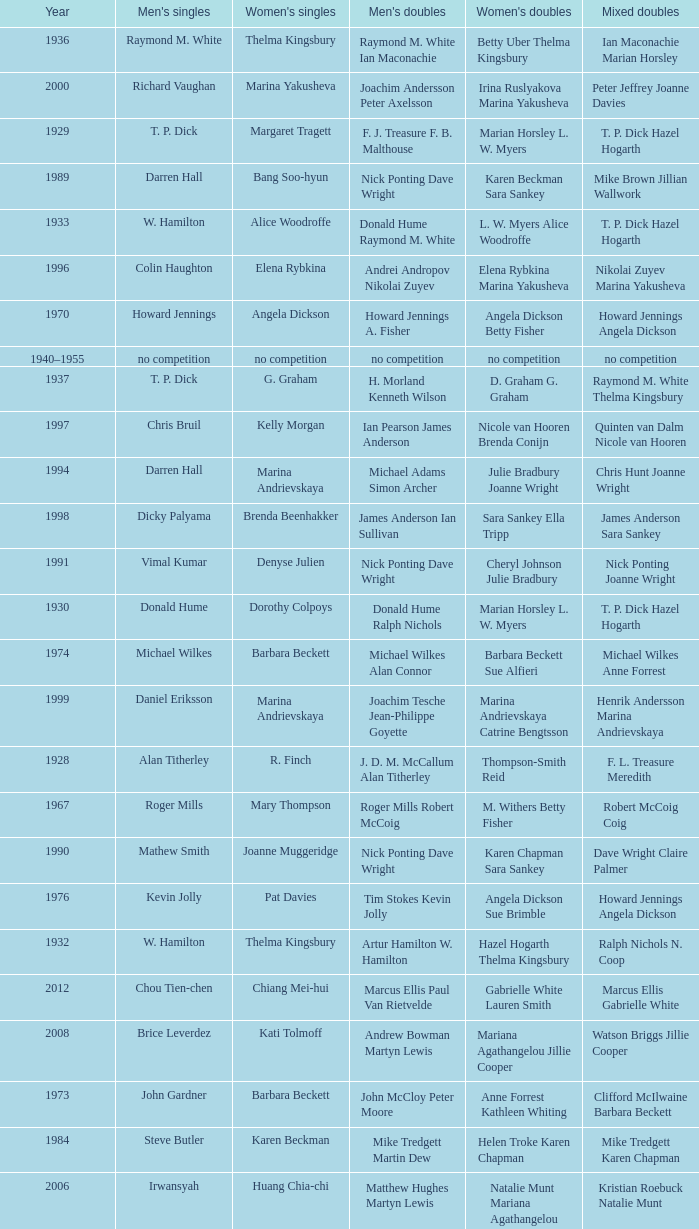Who won the Women's singles, in the year that Raymond M. White won the Men's singles and that W. Hamilton Ian Maconachie won the Men's doubles? Thelma Kingsbury. Help me parse the entirety of this table. {'header': ['Year', "Men's singles", "Women's singles", "Men's doubles", "Women's doubles", 'Mixed doubles'], 'rows': [['1936', 'Raymond M. White', 'Thelma Kingsbury', 'Raymond M. White Ian Maconachie', 'Betty Uber Thelma Kingsbury', 'Ian Maconachie Marian Horsley'], ['2000', 'Richard Vaughan', 'Marina Yakusheva', 'Joachim Andersson Peter Axelsson', 'Irina Ruslyakova Marina Yakusheva', 'Peter Jeffrey Joanne Davies'], ['1929', 'T. P. Dick', 'Margaret Tragett', 'F. J. Treasure F. B. Malthouse', 'Marian Horsley L. W. Myers', 'T. P. Dick Hazel Hogarth'], ['1989', 'Darren Hall', 'Bang Soo-hyun', 'Nick Ponting Dave Wright', 'Karen Beckman Sara Sankey', 'Mike Brown Jillian Wallwork'], ['1933', 'W. Hamilton', 'Alice Woodroffe', 'Donald Hume Raymond M. White', 'L. W. Myers Alice Woodroffe', 'T. P. Dick Hazel Hogarth'], ['1996', 'Colin Haughton', 'Elena Rybkina', 'Andrei Andropov Nikolai Zuyev', 'Elena Rybkina Marina Yakusheva', 'Nikolai Zuyev Marina Yakusheva'], ['1970', 'Howard Jennings', 'Angela Dickson', 'Howard Jennings A. Fisher', 'Angela Dickson Betty Fisher', 'Howard Jennings Angela Dickson'], ['1940–1955', 'no competition', 'no competition', 'no competition', 'no competition', 'no competition'], ['1937', 'T. P. Dick', 'G. Graham', 'H. Morland Kenneth Wilson', 'D. Graham G. Graham', 'Raymond M. White Thelma Kingsbury'], ['1997', 'Chris Bruil', 'Kelly Morgan', 'Ian Pearson James Anderson', 'Nicole van Hooren Brenda Conijn', 'Quinten van Dalm Nicole van Hooren'], ['1994', 'Darren Hall', 'Marina Andrievskaya', 'Michael Adams Simon Archer', 'Julie Bradbury Joanne Wright', 'Chris Hunt Joanne Wright'], ['1998', 'Dicky Palyama', 'Brenda Beenhakker', 'James Anderson Ian Sullivan', 'Sara Sankey Ella Tripp', 'James Anderson Sara Sankey'], ['1991', 'Vimal Kumar', 'Denyse Julien', 'Nick Ponting Dave Wright', 'Cheryl Johnson Julie Bradbury', 'Nick Ponting Joanne Wright'], ['1930', 'Donald Hume', 'Dorothy Colpoys', 'Donald Hume Ralph Nichols', 'Marian Horsley L. W. Myers', 'T. P. Dick Hazel Hogarth'], ['1974', 'Michael Wilkes', 'Barbara Beckett', 'Michael Wilkes Alan Connor', 'Barbara Beckett Sue Alfieri', 'Michael Wilkes Anne Forrest'], ['1999', 'Daniel Eriksson', 'Marina Andrievskaya', 'Joachim Tesche Jean-Philippe Goyette', 'Marina Andrievskaya Catrine Bengtsson', 'Henrik Andersson Marina Andrievskaya'], ['1928', 'Alan Titherley', 'R. Finch', 'J. D. M. McCallum Alan Titherley', 'Thompson-Smith Reid', 'F. L. Treasure Meredith'], ['1967', 'Roger Mills', 'Mary Thompson', 'Roger Mills Robert McCoig', 'M. Withers Betty Fisher', 'Robert McCoig Coig'], ['1990', 'Mathew Smith', 'Joanne Muggeridge', 'Nick Ponting Dave Wright', 'Karen Chapman Sara Sankey', 'Dave Wright Claire Palmer'], ['1976', 'Kevin Jolly', 'Pat Davies', 'Tim Stokes Kevin Jolly', 'Angela Dickson Sue Brimble', 'Howard Jennings Angela Dickson'], ['1932', 'W. Hamilton', 'Thelma Kingsbury', 'Artur Hamilton W. Hamilton', 'Hazel Hogarth Thelma Kingsbury', 'Ralph Nichols N. Coop'], ['2012', 'Chou Tien-chen', 'Chiang Mei-hui', 'Marcus Ellis Paul Van Rietvelde', 'Gabrielle White Lauren Smith', 'Marcus Ellis Gabrielle White'], ['2008', 'Brice Leverdez', 'Kati Tolmoff', 'Andrew Bowman Martyn Lewis', 'Mariana Agathangelou Jillie Cooper', 'Watson Briggs Jillie Cooper'], ['1973', 'John Gardner', 'Barbara Beckett', 'John McCloy Peter Moore', 'Anne Forrest Kathleen Whiting', 'Clifford McIlwaine Barbara Beckett'], ['1984', 'Steve Butler', 'Karen Beckman', 'Mike Tredgett Martin Dew', 'Helen Troke Karen Chapman', 'Mike Tredgett Karen Chapman'], ['2006', 'Irwansyah', 'Huang Chia-chi', 'Matthew Hughes Martyn Lewis', 'Natalie Munt Mariana Agathangelou', 'Kristian Roebuck Natalie Munt'], ['1980', 'Thomas Kihlström', 'Jane Webster', 'Thomas Kihlström Bengt Fröman', 'Jane Webster Karen Puttick', 'Billy Gilliland Karen Puttick'], ['2010', 'Pablo Abián', 'Anita Raj Kaur', 'Peter Käsbauer Josche Zurwonne', 'Joanne Quay Swee Ling Anita Raj Kaur', 'Peter Käsbauer Johanna Goliszewski'], ['1982', 'Steve Baddeley', 'Karen Bridge', 'David Eddy Eddy Sutton', 'Karen Chapman Sally Podger', 'Billy Gilliland Karen Chapman'], ['1978', 'Mike Tredgett', 'Gillian Gilks', 'David Eddy Eddy Sutton', 'Barbara Sutton Marjan Ridder', 'Elliot Stuart Gillian Gilks'], ['1987', 'Darren Hall', 'Fiona Elliott', 'Martin Dew Darren Hall', 'Karen Beckman Sara Halsall', 'Martin Dew Gillian Gilks'], ['2011', 'Niluka Karunaratne', 'Nicole Schaller', 'Chris Coles Matthew Nottingham', 'Ng Hui Ern Ng Hui Lin', 'Martin Campbell Ng Hui Lin'], ['1934', 'W. Hamilton', 'Betty Uber', 'Donald Hume Raymond M. White', 'Betty Uber Thelma Kingsbury', 'Donald Hume Betty Uber'], ['1995', 'Peter Rasmussen', 'Denyse Julien', 'Andrei Andropov Nikolai Zuyev', 'Julie Bradbury Joanne Wright', 'Nick Ponting Joanne Wright'], ['1986', 'Darren Hall', 'Fiona Elliott', 'Martin Dew Dipak Tailor', 'Karen Beckman Sara Halsall', 'Jesper Knudsen Nettie Nielsen'], ['1956', 'James P. Doyle', 'H. B. Mercer', 'Desmond Lacey James P. Doyle', 'H. B. Mercer R. Smyth', 'Kenneth Carlisle R. Smyth'], ['1939', 'Tage Madsen', 'Betty Uber', 'Thomas Boyle James Rankin', 'Betty Uber Diana Doveton', 'Thomas Boyle Olive Wilson'], ['1959', 'Hugh Findlay', 'Heather Ward', 'Tony Jordan Hugh Findlay', 'Heather Ward P. E. Broad', 'Hugh Findlay Heather Ward'], ['1971', 'no competition', 'no competition', 'no competition', 'no competition', 'no competition'], ['1981', 'Ray Stevens', 'Gillian Gilks', 'Ray Stevens Mike Tredgett', 'Gillian Gilks Paula Kilvington', 'Mike Tredgett Nora Perry'], ['1977', 'David Eddy', 'Paula Kilvington', 'David Eddy Eddy Sutton', 'Anne Statt Jane Webster', 'David Eddy Barbara Giles'], ['2004', 'Nathan Rice', 'Petya Nedelcheva', 'Reuben Gordown Aji Basuki Sindoro', 'Petya Nedelcheva Yuan Wemyss', 'Matthew Hughes Kelly Morgan'], ['2003', 'Irwansyah', 'Ella Karachkova', 'Ashley Thilthorpe Kristian Roebuck', 'Ella Karachkova Anastasia Russkikh', 'Alexandr Russkikh Anastasia Russkikh'], ['2005', 'Chetan Anand', 'Eleanor Cox', 'Andrew Ellis Dean George', 'Hayley Connor Heather Olver', 'Valiyaveetil Diju Jwala Gutta'], ['1988', 'Vimal Kumar', 'Lee Jung-mi', 'Richard Outterside Mike Brown', 'Fiona Elliott Sara Halsall', 'Martin Dew Gillian Gilks'], ['2001', 'Irwansyah', 'Brenda Beenhakker', 'Vincent Laigle Svetoslav Stoyanov', 'Sara Sankey Ella Tripp', 'Nikolai Zuyev Marina Yakusheva'], ['1931', 'T. P. Dick', 'Dorothy Colpoys', 'T. P. Dick W. Basil Jones', 'Marian Horsley L. W. Myers', 'T. P. Dick Hazel Hogarth'], ['2007', 'Marc Zwiebler', 'Jill Pittard', 'Wojciech Szkudlarczyk Adam Cwalina', 'Chloe Magee Bing Huang', 'Wojciech Szkudlarczyk Malgorzata Kurdelska'], ['1985', 'Morten Frost', 'Charlotte Hattens', 'Billy Gilliland Dan Travers', 'Gillian Gilks Helen Troke', 'Martin Dew Gillian Gilks'], ['1968', 'Roger Mills', 'Julie Charles', 'Roger Mills J. G. Pearson', 'Julie Charles Angela Dickson', 'Roger Mills Julie Charles'], ['1935', 'Raymond M. White', 'Thelma Kingsbury', 'W. Hamilton Ian Maconachie', 'Betty Uber Thelma Kingsbury', 'B. P. Cook Betty Uber'], ['1993', 'Anders Nielsen', 'Sue Louis Lane', 'Nick Ponting Dave Wright', 'Julie Bradbury Sara Sankey', 'Nick Ponting Joanne Wright'], ['1975', 'Michael Wilkes', 'Anne Statt', 'Michael Wilkes Alan Connor', 'Anne Statt Margo Winter', 'Alan Connor Margo Winter'], ['1972', 'Mike Tredgett', 'Betty Fisher', 'P. Smith William Kidd', 'Angela Dickson Betty Fisher', 'Mike Tredgett Kathleen Whiting'], ['2009', 'Kristian Nielsen', 'Tatjana Bibik', 'Vitaliy Durkin Alexandr Nikolaenko', 'Valeria Sorokina Nina Vislova', 'Vitaliy Durkin Nina Vislova'], ['2002', 'Irwansyah', 'Karina de Wit', 'Nikolai Zuyev Stanislav Pukhov', 'Ella Tripp Joanne Wright', 'Nikolai Zuyev Marina Yakusheva'], ['1983', 'Steve Butler', 'Sally Podger', 'Mike Tredgett Dipak Tailor', 'Nora Perry Jane Webster', 'Dipak Tailor Nora Perry'], ['1957', 'Oon Chong Teik', 'Maggie McIntosh', 'Kenneth Derrick A. R. V. Dolman', 'J. A. Russell Maggie McIntosh', 'Kenneth Derrick B. Maxwell'], ['1958', 'Oon Chong Jin', "Mary O'Sullivan", 'Kenneth Derrick A. R. V. Dolman', 'June Timperley Patricia Dolan', 'Oon Chong Jin June Timperley'], ['1938', 'Raymond M. White', 'Daphne Young', 'T. P. Dick H. E. Baldwin', 'L. W. Myers Dorothy Colpoys', 'Thomas Boyle Olive Wilson'], ['1992', 'Wei Yan', 'Fiona Smith', 'Michael Adams Chris Rees', 'Denyse Julien Doris Piché', 'Andy Goode Joanne Wright'], ['1960–1966', 'no competition', 'no competition', 'no competition', 'no competition', 'no competition'], ['1979', 'Kevin Jolly', 'Nora Perry', 'Ray Stevens Mike Tredgett', 'Barbara Sutton Nora Perry', 'Mike Tredgett Nora Perry'], ['1969', 'Howard Jennings', 'Angela Dickson', 'Mike Tredgett A. Finch', 'J. Masters R. Gerrish', 'Howard Jennings Angela Dickson']]} 